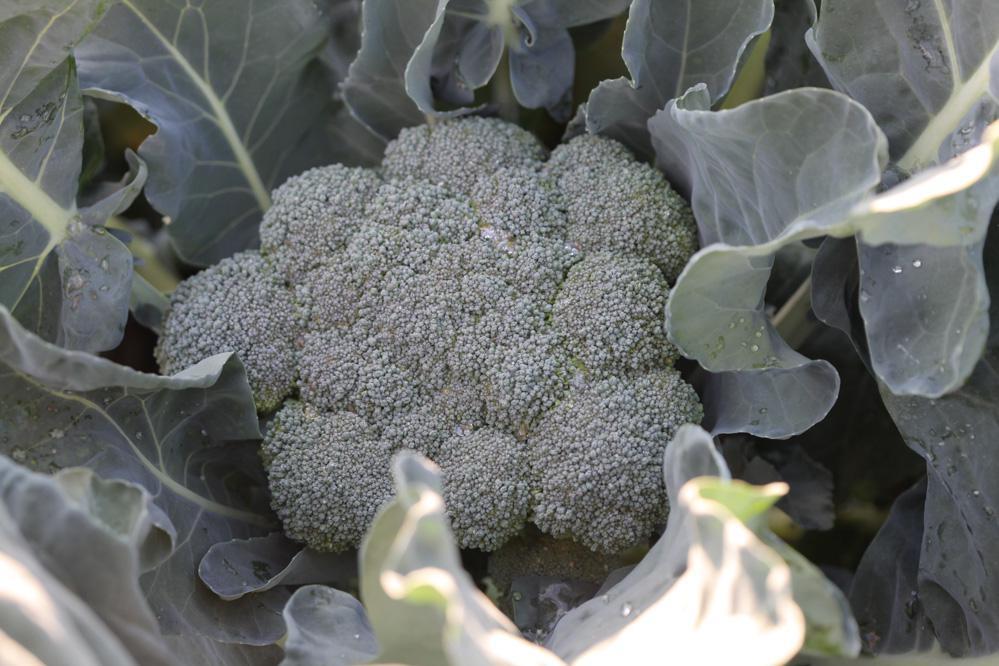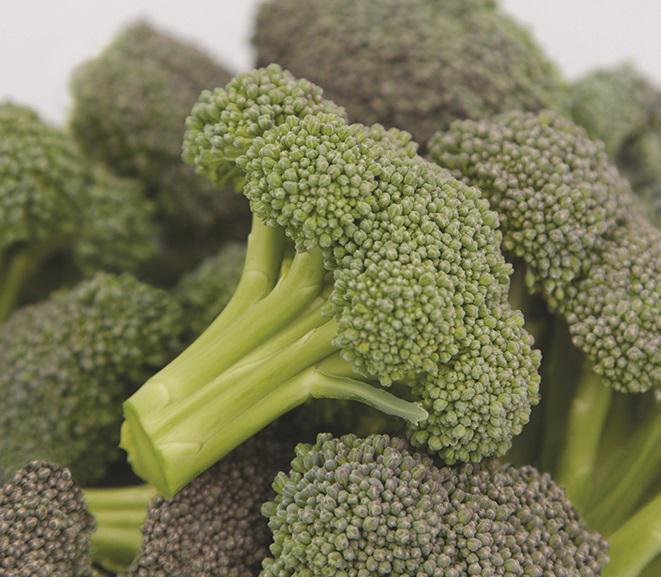The first image is the image on the left, the second image is the image on the right. Analyze the images presented: Is the assertion "In the image to the left, you're able to see some of the broad leaves of the broccoli plant." valid? Answer yes or no. Yes. 